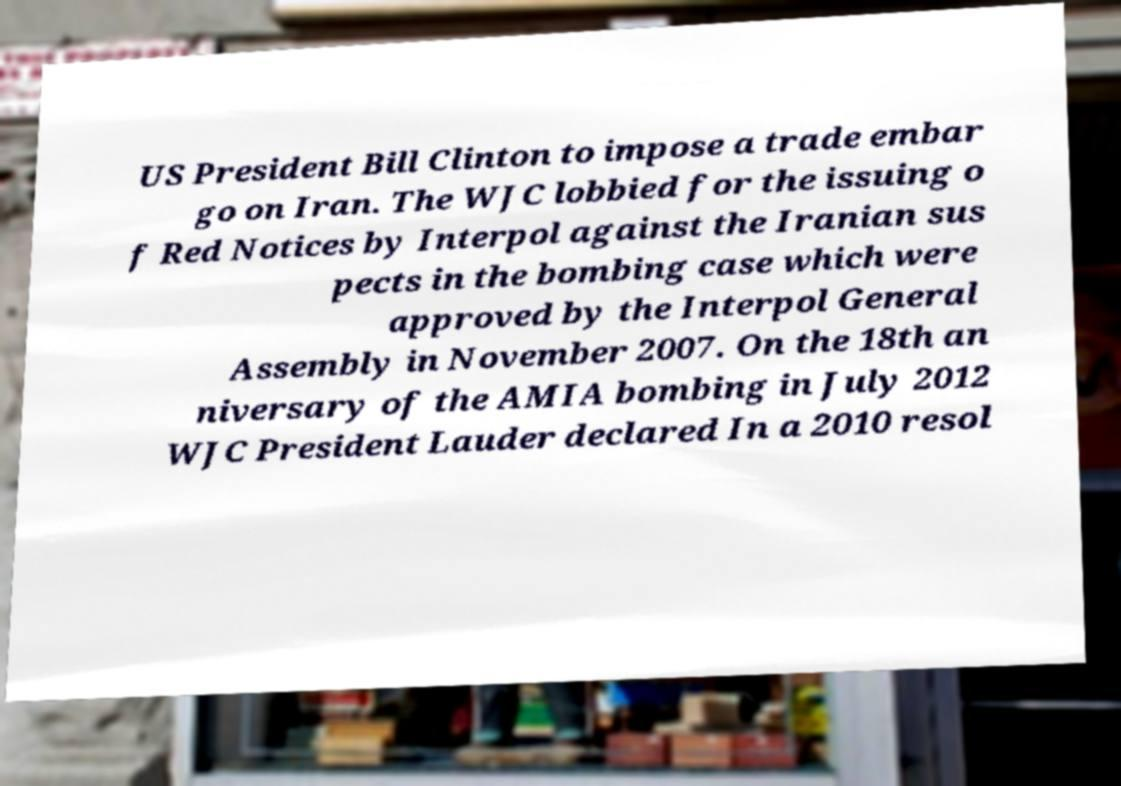Please identify and transcribe the text found in this image. US President Bill Clinton to impose a trade embar go on Iran. The WJC lobbied for the issuing o f Red Notices by Interpol against the Iranian sus pects in the bombing case which were approved by the Interpol General Assembly in November 2007. On the 18th an niversary of the AMIA bombing in July 2012 WJC President Lauder declared In a 2010 resol 